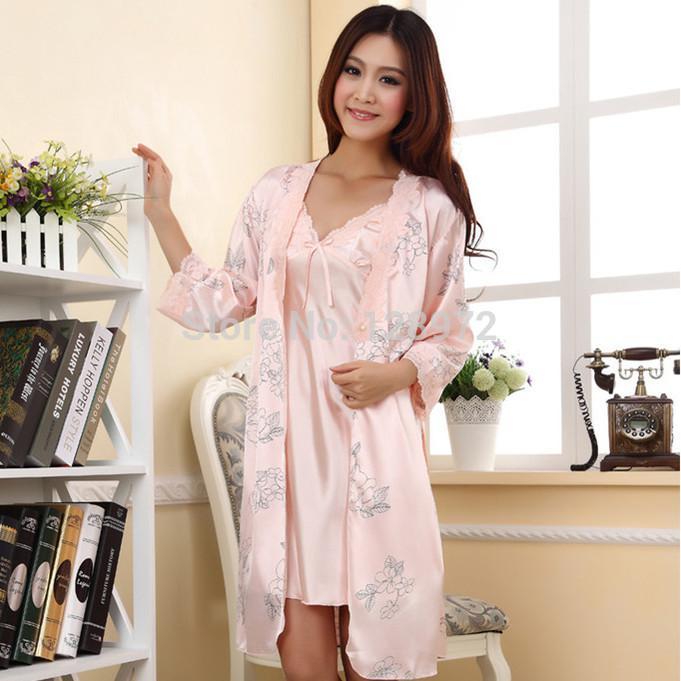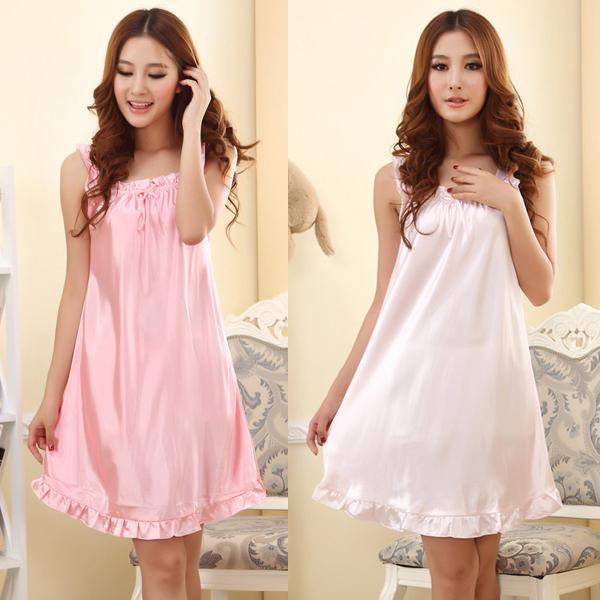The first image is the image on the left, the second image is the image on the right. Analyze the images presented: Is the assertion "The combined images include three models in short gowns in pinkish pastel shades, one wearing a matching robe over the gown." valid? Answer yes or no. Yes. The first image is the image on the left, the second image is the image on the right. Considering the images on both sides, is "there is a woman in long sleeved pink pajamas in front of a window with window blinds" valid? Answer yes or no. No. 